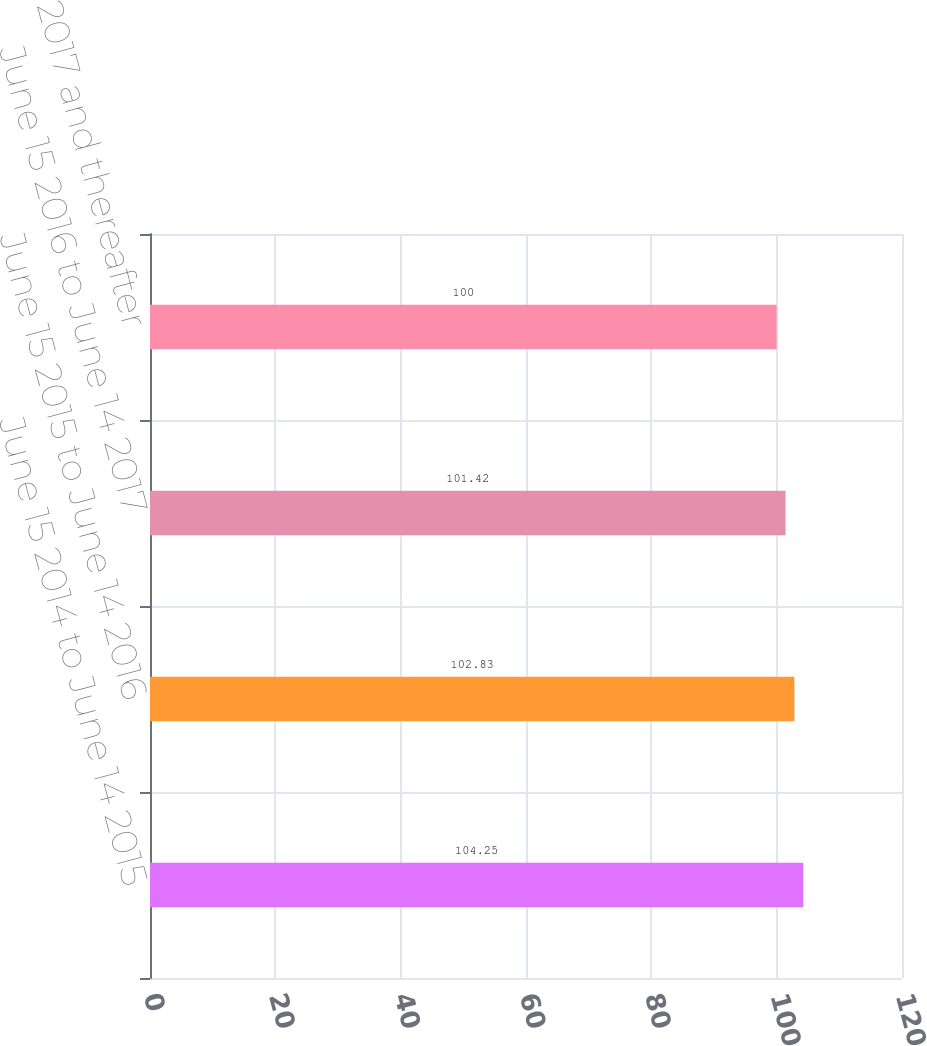Convert chart. <chart><loc_0><loc_0><loc_500><loc_500><bar_chart><fcel>June 15 2014 to June 14 2015<fcel>June 15 2015 to June 14 2016<fcel>June 15 2016 to June 14 2017<fcel>June 15 2017 and thereafter<nl><fcel>104.25<fcel>102.83<fcel>101.42<fcel>100<nl></chart> 